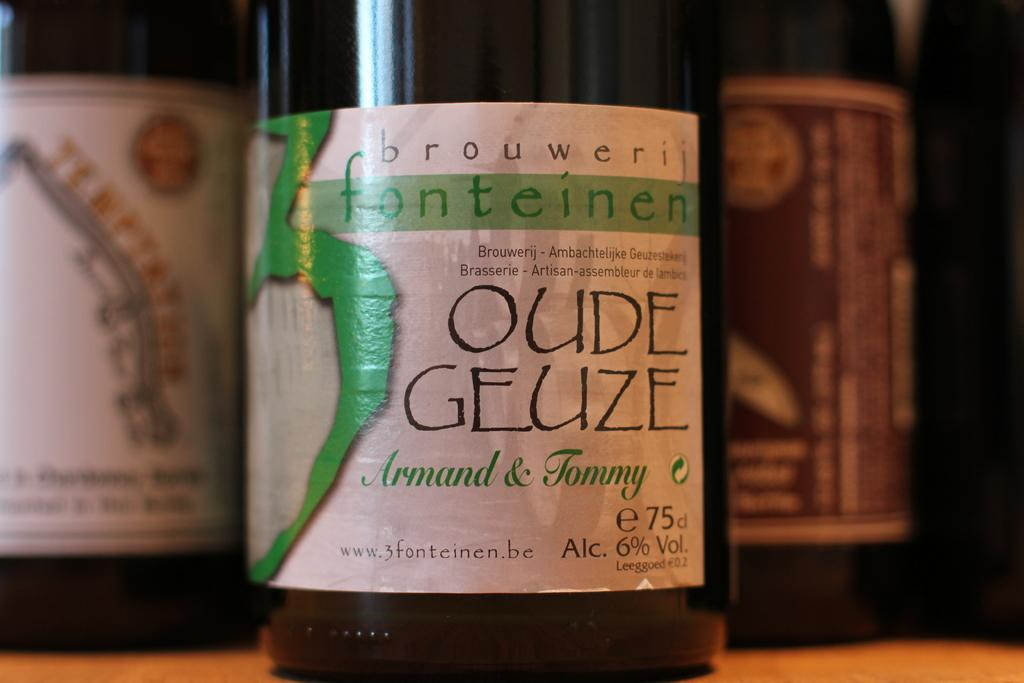Provide a one-sentence caption for the provided image. Bottle of Oude Geuze Armand & Tommy beer on a table. 